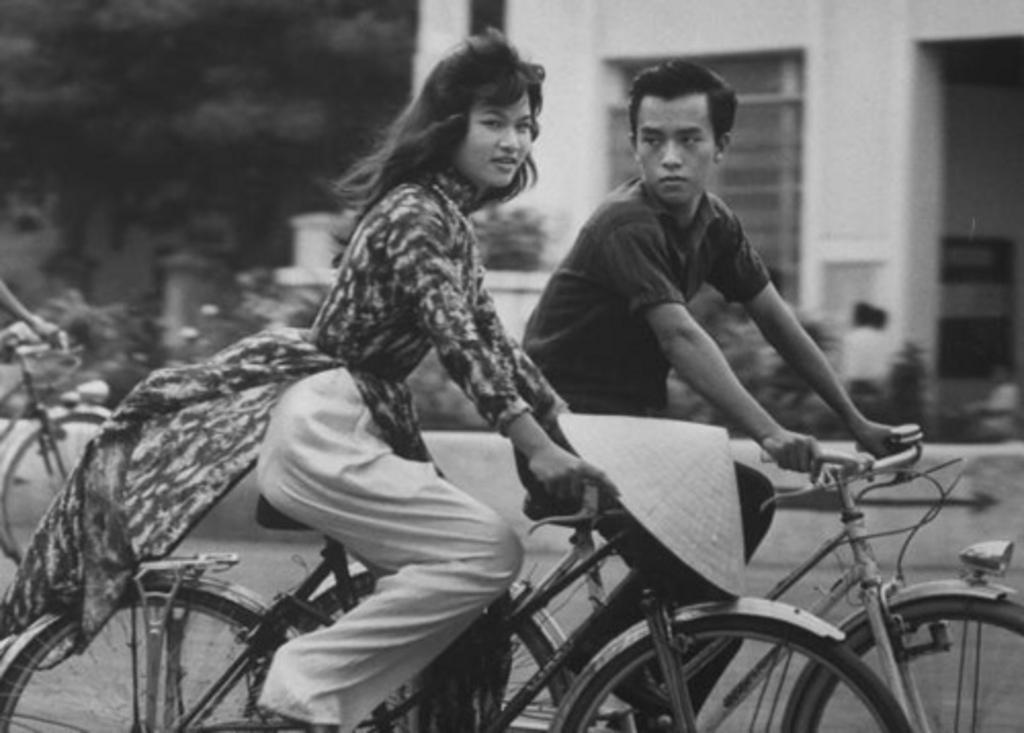Can you describe this image briefly? This is a black and white picture. Here we can see a women and a man on the bicycles. On the background we can see a building. And this is tree and there are some plants. 